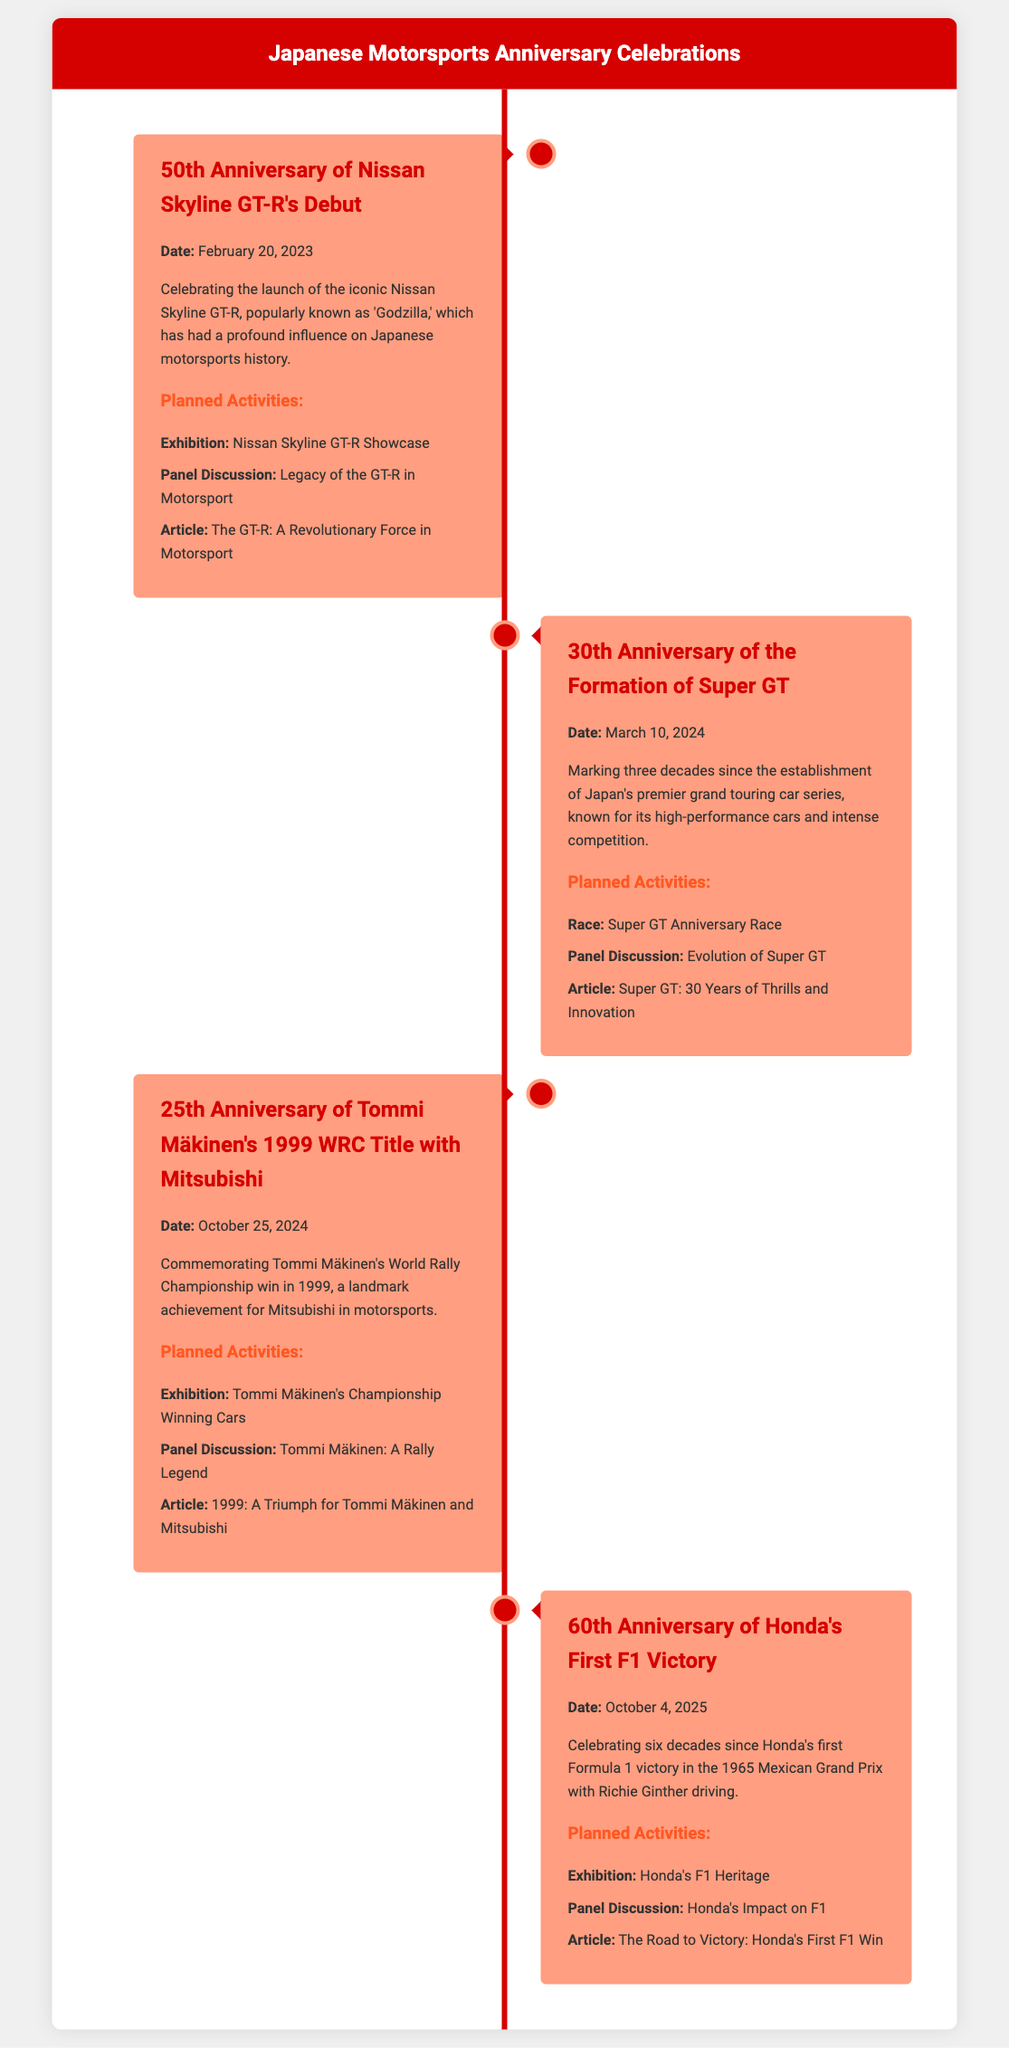What is the date of the 50th Anniversary of Nissan Skyline GT-R's Debut? The document states that the event is on February 20, 2023.
Answer: February 20, 2023 What anniversary is celebrated on March 10, 2024? The document mentions the 30th Anniversary of the Formation of Super GT.
Answer: 30th Anniversary of the Formation of Super GT How long ago is the 60th Anniversary of Honda's First F1 Victory from the current year 2025? The event is in 2025, thus it is being celebrated 60 years after Honda's first victory in 1965.
Answer: 60 years What kind of panel discussion is planned for the 25th Anniversary of Tommi Mäkinen's WRC Title? The document specifies a discussion titled "Tommi Mäkinen: A Rally Legend" to commemorate the rally champion.
Answer: Tommi Mäkinen: A Rally Legend How many planned activities are mentioned for the 50th Anniversary of Nissan Skyline GT-R's Debut? The document lists three activities for this anniversary celebration: an exhibition, a panel discussion, and an article.
Answer: Three activities Which car model is recognized as 'Godzilla'? The document describes the Nissan Skyline GT-R as being popularly known as 'Godzilla.'
Answer: Nissan Skyline GT-R What is the publication date for the article related to the 30th Anniversary of Super GT? The article is dated for publication in conjunction with the anniversary event on March 10, 2024.
Answer: March 10, 2024 What type of event is scheduled for October 4, 2025? The document indicates that an exhibition focusing on Honda's F1 Heritage is planned for this date.
Answer: Exhibition What significant motorsports achievement is commemorated in the document for Tommi Mäkinen? The document celebrates Tommi Mäkinen's World Rally Championship win in 1999 as a significant achievement for Mitsubishi.
Answer: World Rally Championship win in 1999 